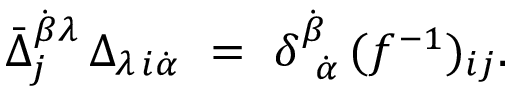Convert formula to latex. <formula><loc_0><loc_0><loc_500><loc_500>\bar { \Delta } _ { j } ^ { \dot { \beta } \lambda } \, \Delta _ { \lambda \, i \dot { \alpha } } \ = \ \delta _ { \ \dot { \alpha } } ^ { \dot { \beta } } \, ( f ^ { - 1 } ) _ { i j } .</formula> 